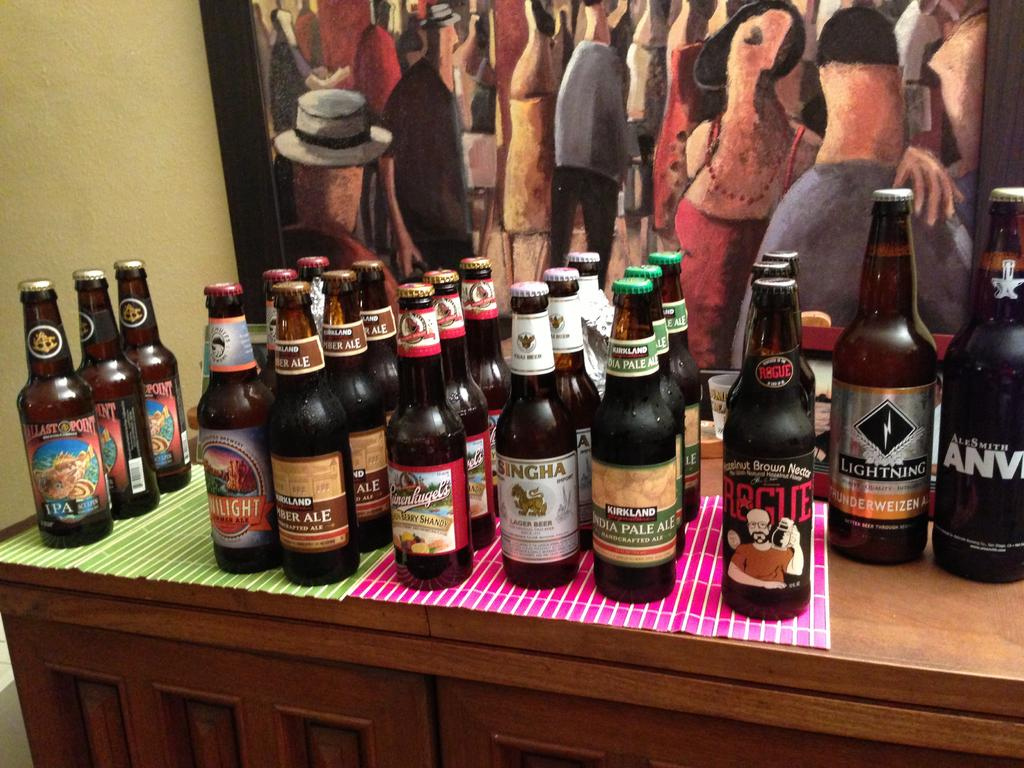<image>
Summarize the visual content of the image. A bottle of Rogue sits next to several other types of beer. 